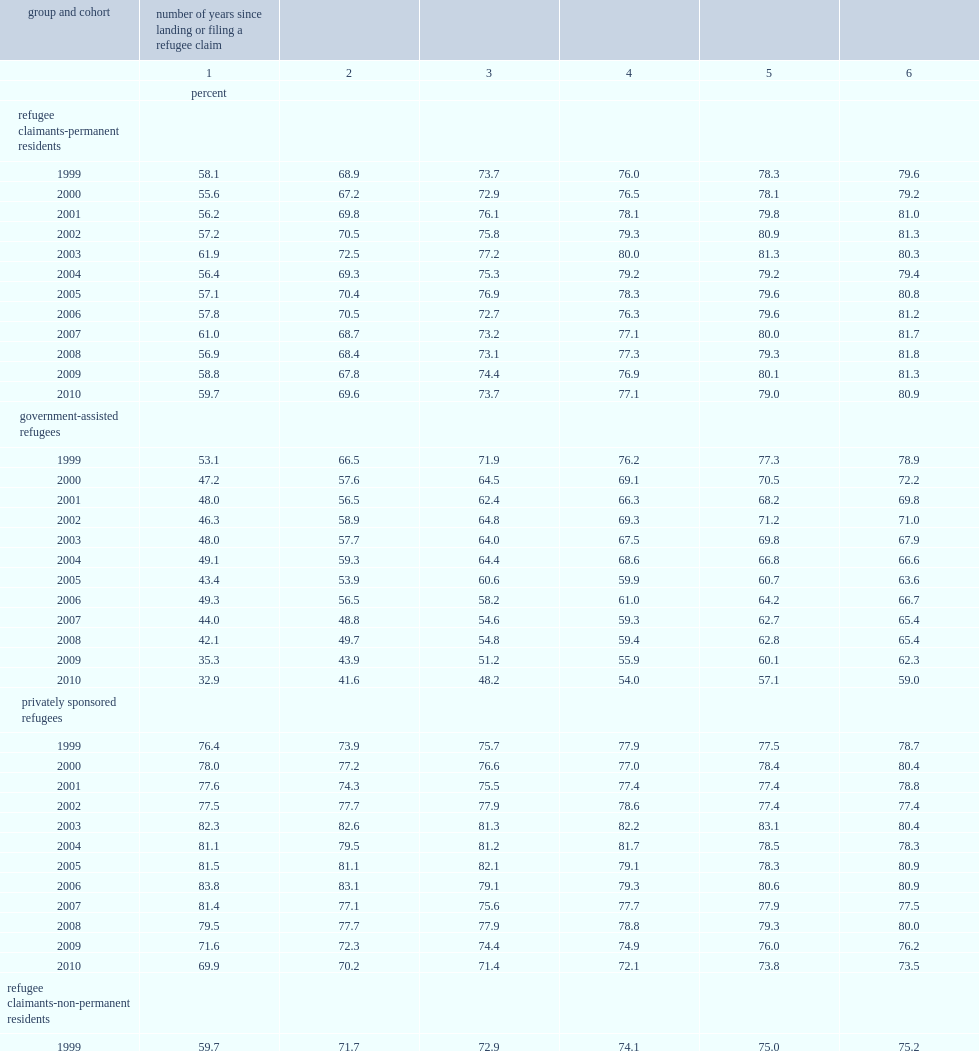What is the percentage of rc-prs who made their claim in 2010 reported employment income in the following tax year? 59.7. What is the percentage of rc-prs who made their claim in 2010 reported employment income after six years? 80.9. What is the perentage of gars who landed in 1999 reported employment income in the first year after landing? 53.1. What is the perentage of gars who landed in 2010 reported employment income in the first year after landing? 32.9. From the 1999 cohort to the 2010 cohort,how many percentage ponit of psrs who received employment income six years after landing has declined ? 5.2. 